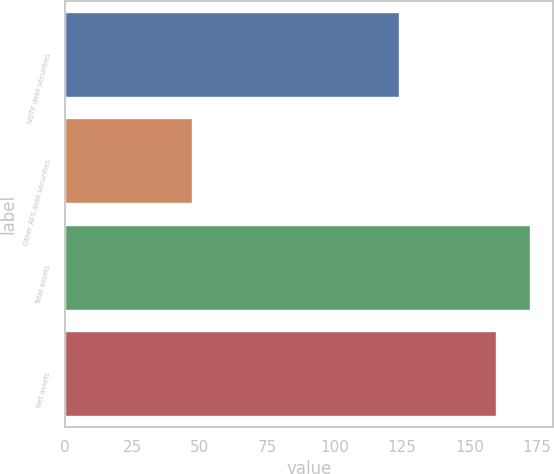Convert chart. <chart><loc_0><loc_0><loc_500><loc_500><bar_chart><fcel>NDTF debt securities<fcel>Other AFS debt securities<fcel>Total assets<fcel>Net assets<nl><fcel>124<fcel>47<fcel>172.5<fcel>160<nl></chart> 